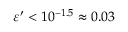Convert formula to latex. <formula><loc_0><loc_0><loc_500><loc_500>\varepsilon ^ { \prime } < 1 0 ^ { - 1 . 5 } \approx 0 . 0 3</formula> 